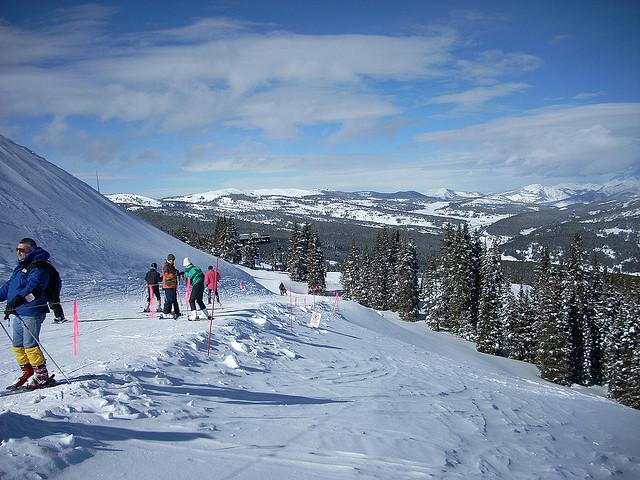What color does the person in the back have on?
Give a very brief answer. Pink. Is this an intimidating hill to ski?
Keep it brief. No. Are both skiers going up hill?
Be succinct. No. Is one woman far behind?
Give a very brief answer. Yes. Is it summer?
Be succinct. No. Are the trees green?
Answer briefly. Yes. Is it cloudy?
Keep it brief. Yes. 